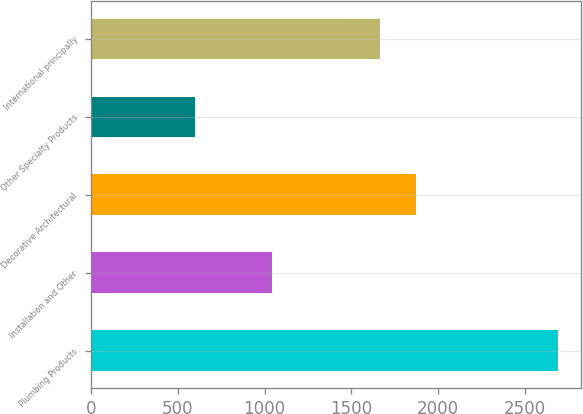<chart> <loc_0><loc_0><loc_500><loc_500><bar_chart><fcel>Plumbing Products<fcel>Installation and Other<fcel>Decorative Architectural<fcel>Other Specialty Products<fcel>International principally<nl><fcel>2692<fcel>1041<fcel>1872.6<fcel>596<fcel>1663<nl></chart> 